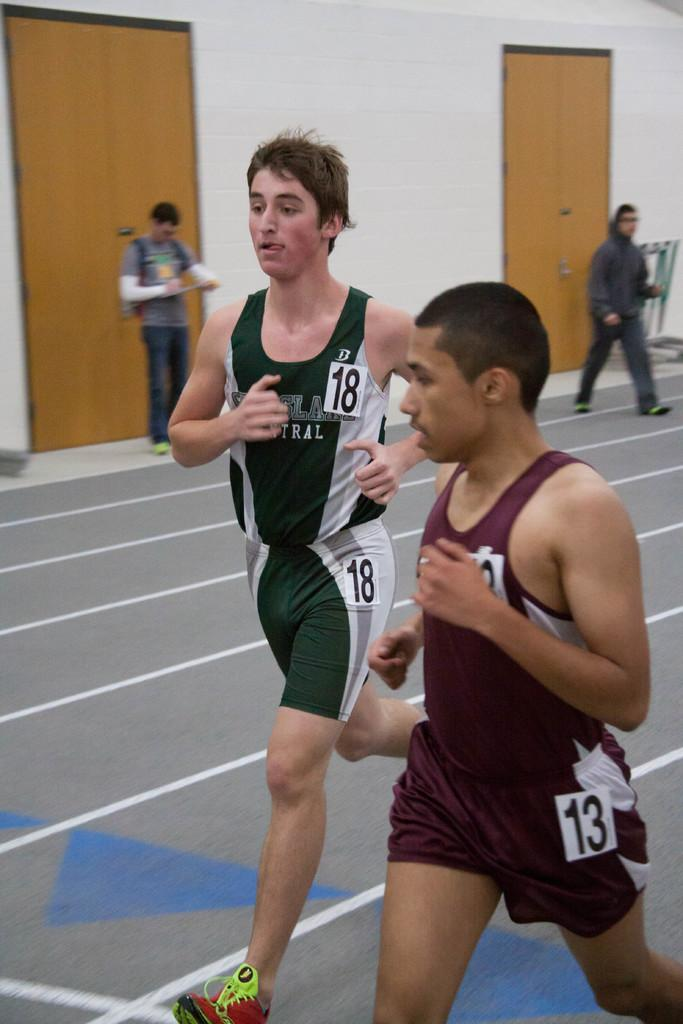What are the two persons in the image doing? There are two persons running and two persons walking in the image. What can be seen in the background of the image? There is a wall visible in the image. How many doors are present on the wall? There are two doors on the wall. What advice does the aunt give in the story depicted in the image? There is no aunt or story present in the image; it features two persons running and two persons walking, along with a wall and two doors. 